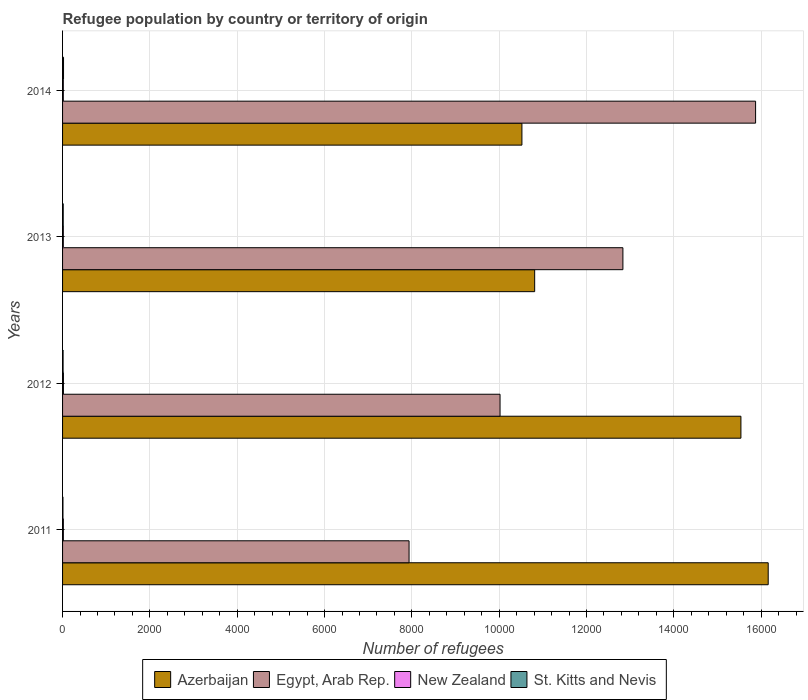How many bars are there on the 4th tick from the top?
Your answer should be very brief. 4. How many bars are there on the 3rd tick from the bottom?
Provide a short and direct response. 4. What is the label of the 2nd group of bars from the top?
Keep it short and to the point. 2013. What is the number of refugees in Egypt, Arab Rep. in 2012?
Ensure brevity in your answer.  1.00e+04. Across all years, what is the maximum number of refugees in Egypt, Arab Rep.?
Offer a terse response. 1.59e+04. Across all years, what is the minimum number of refugees in Azerbaijan?
Offer a terse response. 1.05e+04. In which year was the number of refugees in New Zealand maximum?
Your answer should be very brief. 2012. In which year was the number of refugees in Azerbaijan minimum?
Give a very brief answer. 2014. What is the difference between the number of refugees in Egypt, Arab Rep. in 2011 and the number of refugees in Azerbaijan in 2013?
Give a very brief answer. -2877. What is the average number of refugees in Azerbaijan per year?
Provide a short and direct response. 1.33e+04. In the year 2013, what is the difference between the number of refugees in St. Kitts and Nevis and number of refugees in Egypt, Arab Rep.?
Your answer should be compact. -1.28e+04. In how many years, is the number of refugees in Egypt, Arab Rep. greater than 9200 ?
Provide a short and direct response. 3. What is the ratio of the number of refugees in Azerbaijan in 2012 to that in 2014?
Your response must be concise. 1.48. Is the number of refugees in New Zealand in 2011 less than that in 2014?
Offer a very short reply. No. Is the difference between the number of refugees in St. Kitts and Nevis in 2012 and 2014 greater than the difference between the number of refugees in Egypt, Arab Rep. in 2012 and 2014?
Provide a short and direct response. Yes. What is the difference between the highest and the second highest number of refugees in New Zealand?
Give a very brief answer. 2. What is the difference between the highest and the lowest number of refugees in Azerbaijan?
Keep it short and to the point. 5641. Is it the case that in every year, the sum of the number of refugees in St. Kitts and Nevis and number of refugees in Azerbaijan is greater than the sum of number of refugees in New Zealand and number of refugees in Egypt, Arab Rep.?
Ensure brevity in your answer.  No. What does the 4th bar from the top in 2011 represents?
Offer a very short reply. Azerbaijan. What does the 4th bar from the bottom in 2014 represents?
Your response must be concise. St. Kitts and Nevis. Is it the case that in every year, the sum of the number of refugees in St. Kitts and Nevis and number of refugees in Egypt, Arab Rep. is greater than the number of refugees in Azerbaijan?
Your answer should be very brief. No. Are all the bars in the graph horizontal?
Provide a short and direct response. Yes. Does the graph contain grids?
Provide a succinct answer. Yes. How are the legend labels stacked?
Your answer should be compact. Horizontal. What is the title of the graph?
Offer a very short reply. Refugee population by country or territory of origin. Does "Norway" appear as one of the legend labels in the graph?
Make the answer very short. No. What is the label or title of the X-axis?
Give a very brief answer. Number of refugees. What is the label or title of the Y-axis?
Provide a succinct answer. Years. What is the Number of refugees of Azerbaijan in 2011?
Offer a very short reply. 1.62e+04. What is the Number of refugees in Egypt, Arab Rep. in 2011?
Provide a succinct answer. 7936. What is the Number of refugees of New Zealand in 2011?
Give a very brief answer. 18. What is the Number of refugees of Azerbaijan in 2012?
Offer a terse response. 1.55e+04. What is the Number of refugees of Egypt, Arab Rep. in 2012?
Give a very brief answer. 1.00e+04. What is the Number of refugees of St. Kitts and Nevis in 2012?
Offer a very short reply. 12. What is the Number of refugees in Azerbaijan in 2013?
Your answer should be compact. 1.08e+04. What is the Number of refugees in Egypt, Arab Rep. in 2013?
Keep it short and to the point. 1.28e+04. What is the Number of refugees of St. Kitts and Nevis in 2013?
Your response must be concise. 15. What is the Number of refugees in Azerbaijan in 2014?
Your answer should be compact. 1.05e+04. What is the Number of refugees of Egypt, Arab Rep. in 2014?
Ensure brevity in your answer.  1.59e+04. Across all years, what is the maximum Number of refugees in Azerbaijan?
Provide a short and direct response. 1.62e+04. Across all years, what is the maximum Number of refugees in Egypt, Arab Rep.?
Keep it short and to the point. 1.59e+04. Across all years, what is the maximum Number of refugees in New Zealand?
Make the answer very short. 20. Across all years, what is the maximum Number of refugees of St. Kitts and Nevis?
Your answer should be very brief. 22. Across all years, what is the minimum Number of refugees of Azerbaijan?
Give a very brief answer. 1.05e+04. Across all years, what is the minimum Number of refugees in Egypt, Arab Rep.?
Ensure brevity in your answer.  7936. Across all years, what is the minimum Number of refugees of St. Kitts and Nevis?
Give a very brief answer. 9. What is the total Number of refugees in Azerbaijan in the graph?
Provide a succinct answer. 5.30e+04. What is the total Number of refugees of Egypt, Arab Rep. in the graph?
Your answer should be compact. 4.67e+04. What is the total Number of refugees in St. Kitts and Nevis in the graph?
Your response must be concise. 58. What is the difference between the Number of refugees of Azerbaijan in 2011 and that in 2012?
Keep it short and to the point. 625. What is the difference between the Number of refugees of Egypt, Arab Rep. in 2011 and that in 2012?
Ensure brevity in your answer.  -2084. What is the difference between the Number of refugees in Azerbaijan in 2011 and that in 2013?
Offer a very short reply. 5349. What is the difference between the Number of refugees of Egypt, Arab Rep. in 2011 and that in 2013?
Your answer should be compact. -4898. What is the difference between the Number of refugees of Azerbaijan in 2011 and that in 2014?
Ensure brevity in your answer.  5641. What is the difference between the Number of refugees in Egypt, Arab Rep. in 2011 and that in 2014?
Your answer should be compact. -7937. What is the difference between the Number of refugees in St. Kitts and Nevis in 2011 and that in 2014?
Offer a terse response. -13. What is the difference between the Number of refugees in Azerbaijan in 2012 and that in 2013?
Offer a very short reply. 4724. What is the difference between the Number of refugees in Egypt, Arab Rep. in 2012 and that in 2013?
Offer a very short reply. -2814. What is the difference between the Number of refugees of New Zealand in 2012 and that in 2013?
Your response must be concise. 3. What is the difference between the Number of refugees in Azerbaijan in 2012 and that in 2014?
Offer a very short reply. 5016. What is the difference between the Number of refugees of Egypt, Arab Rep. in 2012 and that in 2014?
Provide a short and direct response. -5853. What is the difference between the Number of refugees in St. Kitts and Nevis in 2012 and that in 2014?
Your answer should be very brief. -10. What is the difference between the Number of refugees in Azerbaijan in 2013 and that in 2014?
Keep it short and to the point. 292. What is the difference between the Number of refugees of Egypt, Arab Rep. in 2013 and that in 2014?
Give a very brief answer. -3039. What is the difference between the Number of refugees in Azerbaijan in 2011 and the Number of refugees in Egypt, Arab Rep. in 2012?
Give a very brief answer. 6142. What is the difference between the Number of refugees in Azerbaijan in 2011 and the Number of refugees in New Zealand in 2012?
Keep it short and to the point. 1.61e+04. What is the difference between the Number of refugees in Azerbaijan in 2011 and the Number of refugees in St. Kitts and Nevis in 2012?
Make the answer very short. 1.62e+04. What is the difference between the Number of refugees in Egypt, Arab Rep. in 2011 and the Number of refugees in New Zealand in 2012?
Your answer should be compact. 7916. What is the difference between the Number of refugees of Egypt, Arab Rep. in 2011 and the Number of refugees of St. Kitts and Nevis in 2012?
Offer a terse response. 7924. What is the difference between the Number of refugees in Azerbaijan in 2011 and the Number of refugees in Egypt, Arab Rep. in 2013?
Ensure brevity in your answer.  3328. What is the difference between the Number of refugees in Azerbaijan in 2011 and the Number of refugees in New Zealand in 2013?
Provide a succinct answer. 1.61e+04. What is the difference between the Number of refugees in Azerbaijan in 2011 and the Number of refugees in St. Kitts and Nevis in 2013?
Provide a succinct answer. 1.61e+04. What is the difference between the Number of refugees of Egypt, Arab Rep. in 2011 and the Number of refugees of New Zealand in 2013?
Make the answer very short. 7919. What is the difference between the Number of refugees in Egypt, Arab Rep. in 2011 and the Number of refugees in St. Kitts and Nevis in 2013?
Offer a very short reply. 7921. What is the difference between the Number of refugees in New Zealand in 2011 and the Number of refugees in St. Kitts and Nevis in 2013?
Ensure brevity in your answer.  3. What is the difference between the Number of refugees in Azerbaijan in 2011 and the Number of refugees in Egypt, Arab Rep. in 2014?
Provide a short and direct response. 289. What is the difference between the Number of refugees in Azerbaijan in 2011 and the Number of refugees in New Zealand in 2014?
Give a very brief answer. 1.61e+04. What is the difference between the Number of refugees in Azerbaijan in 2011 and the Number of refugees in St. Kitts and Nevis in 2014?
Your answer should be very brief. 1.61e+04. What is the difference between the Number of refugees of Egypt, Arab Rep. in 2011 and the Number of refugees of New Zealand in 2014?
Your response must be concise. 7919. What is the difference between the Number of refugees in Egypt, Arab Rep. in 2011 and the Number of refugees in St. Kitts and Nevis in 2014?
Make the answer very short. 7914. What is the difference between the Number of refugees in Azerbaijan in 2012 and the Number of refugees in Egypt, Arab Rep. in 2013?
Your answer should be very brief. 2703. What is the difference between the Number of refugees of Azerbaijan in 2012 and the Number of refugees of New Zealand in 2013?
Your answer should be compact. 1.55e+04. What is the difference between the Number of refugees of Azerbaijan in 2012 and the Number of refugees of St. Kitts and Nevis in 2013?
Keep it short and to the point. 1.55e+04. What is the difference between the Number of refugees in Egypt, Arab Rep. in 2012 and the Number of refugees in New Zealand in 2013?
Make the answer very short. 1.00e+04. What is the difference between the Number of refugees of Egypt, Arab Rep. in 2012 and the Number of refugees of St. Kitts and Nevis in 2013?
Make the answer very short. 1.00e+04. What is the difference between the Number of refugees in Azerbaijan in 2012 and the Number of refugees in Egypt, Arab Rep. in 2014?
Give a very brief answer. -336. What is the difference between the Number of refugees in Azerbaijan in 2012 and the Number of refugees in New Zealand in 2014?
Offer a terse response. 1.55e+04. What is the difference between the Number of refugees of Azerbaijan in 2012 and the Number of refugees of St. Kitts and Nevis in 2014?
Your answer should be compact. 1.55e+04. What is the difference between the Number of refugees in Egypt, Arab Rep. in 2012 and the Number of refugees in New Zealand in 2014?
Offer a terse response. 1.00e+04. What is the difference between the Number of refugees of Egypt, Arab Rep. in 2012 and the Number of refugees of St. Kitts and Nevis in 2014?
Offer a very short reply. 9998. What is the difference between the Number of refugees in New Zealand in 2012 and the Number of refugees in St. Kitts and Nevis in 2014?
Provide a short and direct response. -2. What is the difference between the Number of refugees of Azerbaijan in 2013 and the Number of refugees of Egypt, Arab Rep. in 2014?
Your answer should be compact. -5060. What is the difference between the Number of refugees of Azerbaijan in 2013 and the Number of refugees of New Zealand in 2014?
Ensure brevity in your answer.  1.08e+04. What is the difference between the Number of refugees in Azerbaijan in 2013 and the Number of refugees in St. Kitts and Nevis in 2014?
Your answer should be compact. 1.08e+04. What is the difference between the Number of refugees of Egypt, Arab Rep. in 2013 and the Number of refugees of New Zealand in 2014?
Offer a very short reply. 1.28e+04. What is the difference between the Number of refugees of Egypt, Arab Rep. in 2013 and the Number of refugees of St. Kitts and Nevis in 2014?
Your answer should be very brief. 1.28e+04. What is the average Number of refugees of Azerbaijan per year?
Give a very brief answer. 1.33e+04. What is the average Number of refugees in Egypt, Arab Rep. per year?
Ensure brevity in your answer.  1.17e+04. In the year 2011, what is the difference between the Number of refugees of Azerbaijan and Number of refugees of Egypt, Arab Rep.?
Your response must be concise. 8226. In the year 2011, what is the difference between the Number of refugees of Azerbaijan and Number of refugees of New Zealand?
Your answer should be compact. 1.61e+04. In the year 2011, what is the difference between the Number of refugees in Azerbaijan and Number of refugees in St. Kitts and Nevis?
Offer a terse response. 1.62e+04. In the year 2011, what is the difference between the Number of refugees in Egypt, Arab Rep. and Number of refugees in New Zealand?
Give a very brief answer. 7918. In the year 2011, what is the difference between the Number of refugees of Egypt, Arab Rep. and Number of refugees of St. Kitts and Nevis?
Keep it short and to the point. 7927. In the year 2011, what is the difference between the Number of refugees of New Zealand and Number of refugees of St. Kitts and Nevis?
Provide a short and direct response. 9. In the year 2012, what is the difference between the Number of refugees in Azerbaijan and Number of refugees in Egypt, Arab Rep.?
Your answer should be very brief. 5517. In the year 2012, what is the difference between the Number of refugees of Azerbaijan and Number of refugees of New Zealand?
Make the answer very short. 1.55e+04. In the year 2012, what is the difference between the Number of refugees in Azerbaijan and Number of refugees in St. Kitts and Nevis?
Offer a very short reply. 1.55e+04. In the year 2012, what is the difference between the Number of refugees of Egypt, Arab Rep. and Number of refugees of St. Kitts and Nevis?
Provide a short and direct response. 1.00e+04. In the year 2012, what is the difference between the Number of refugees in New Zealand and Number of refugees in St. Kitts and Nevis?
Provide a succinct answer. 8. In the year 2013, what is the difference between the Number of refugees in Azerbaijan and Number of refugees in Egypt, Arab Rep.?
Offer a very short reply. -2021. In the year 2013, what is the difference between the Number of refugees in Azerbaijan and Number of refugees in New Zealand?
Ensure brevity in your answer.  1.08e+04. In the year 2013, what is the difference between the Number of refugees in Azerbaijan and Number of refugees in St. Kitts and Nevis?
Provide a short and direct response. 1.08e+04. In the year 2013, what is the difference between the Number of refugees in Egypt, Arab Rep. and Number of refugees in New Zealand?
Give a very brief answer. 1.28e+04. In the year 2013, what is the difference between the Number of refugees in Egypt, Arab Rep. and Number of refugees in St. Kitts and Nevis?
Offer a terse response. 1.28e+04. In the year 2014, what is the difference between the Number of refugees of Azerbaijan and Number of refugees of Egypt, Arab Rep.?
Offer a terse response. -5352. In the year 2014, what is the difference between the Number of refugees in Azerbaijan and Number of refugees in New Zealand?
Provide a succinct answer. 1.05e+04. In the year 2014, what is the difference between the Number of refugees of Azerbaijan and Number of refugees of St. Kitts and Nevis?
Your response must be concise. 1.05e+04. In the year 2014, what is the difference between the Number of refugees in Egypt, Arab Rep. and Number of refugees in New Zealand?
Provide a short and direct response. 1.59e+04. In the year 2014, what is the difference between the Number of refugees of Egypt, Arab Rep. and Number of refugees of St. Kitts and Nevis?
Give a very brief answer. 1.59e+04. What is the ratio of the Number of refugees of Azerbaijan in 2011 to that in 2012?
Keep it short and to the point. 1.04. What is the ratio of the Number of refugees of Egypt, Arab Rep. in 2011 to that in 2012?
Your response must be concise. 0.79. What is the ratio of the Number of refugees in Azerbaijan in 2011 to that in 2013?
Ensure brevity in your answer.  1.49. What is the ratio of the Number of refugees in Egypt, Arab Rep. in 2011 to that in 2013?
Make the answer very short. 0.62. What is the ratio of the Number of refugees in New Zealand in 2011 to that in 2013?
Your answer should be very brief. 1.06. What is the ratio of the Number of refugees in St. Kitts and Nevis in 2011 to that in 2013?
Your response must be concise. 0.6. What is the ratio of the Number of refugees of Azerbaijan in 2011 to that in 2014?
Keep it short and to the point. 1.54. What is the ratio of the Number of refugees of Egypt, Arab Rep. in 2011 to that in 2014?
Offer a very short reply. 0.5. What is the ratio of the Number of refugees of New Zealand in 2011 to that in 2014?
Provide a short and direct response. 1.06. What is the ratio of the Number of refugees in St. Kitts and Nevis in 2011 to that in 2014?
Provide a short and direct response. 0.41. What is the ratio of the Number of refugees in Azerbaijan in 2012 to that in 2013?
Offer a very short reply. 1.44. What is the ratio of the Number of refugees of Egypt, Arab Rep. in 2012 to that in 2013?
Give a very brief answer. 0.78. What is the ratio of the Number of refugees of New Zealand in 2012 to that in 2013?
Offer a terse response. 1.18. What is the ratio of the Number of refugees of St. Kitts and Nevis in 2012 to that in 2013?
Offer a very short reply. 0.8. What is the ratio of the Number of refugees of Azerbaijan in 2012 to that in 2014?
Your answer should be very brief. 1.48. What is the ratio of the Number of refugees in Egypt, Arab Rep. in 2012 to that in 2014?
Ensure brevity in your answer.  0.63. What is the ratio of the Number of refugees of New Zealand in 2012 to that in 2014?
Keep it short and to the point. 1.18. What is the ratio of the Number of refugees in St. Kitts and Nevis in 2012 to that in 2014?
Make the answer very short. 0.55. What is the ratio of the Number of refugees of Azerbaijan in 2013 to that in 2014?
Your response must be concise. 1.03. What is the ratio of the Number of refugees of Egypt, Arab Rep. in 2013 to that in 2014?
Make the answer very short. 0.81. What is the ratio of the Number of refugees of New Zealand in 2013 to that in 2014?
Offer a terse response. 1. What is the ratio of the Number of refugees of St. Kitts and Nevis in 2013 to that in 2014?
Give a very brief answer. 0.68. What is the difference between the highest and the second highest Number of refugees of Azerbaijan?
Ensure brevity in your answer.  625. What is the difference between the highest and the second highest Number of refugees in Egypt, Arab Rep.?
Give a very brief answer. 3039. What is the difference between the highest and the lowest Number of refugees of Azerbaijan?
Provide a succinct answer. 5641. What is the difference between the highest and the lowest Number of refugees in Egypt, Arab Rep.?
Your answer should be compact. 7937. What is the difference between the highest and the lowest Number of refugees in St. Kitts and Nevis?
Keep it short and to the point. 13. 